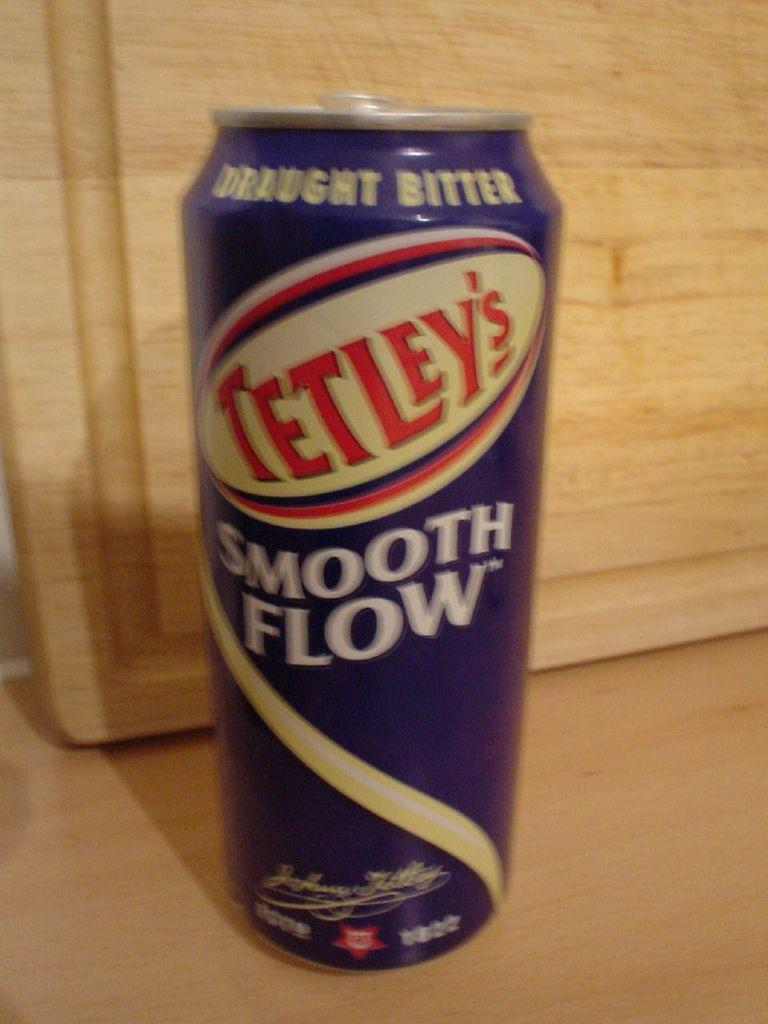<image>
Provide a brief description of the given image. a close up of a bottle of Tetleys Smooth Flow 